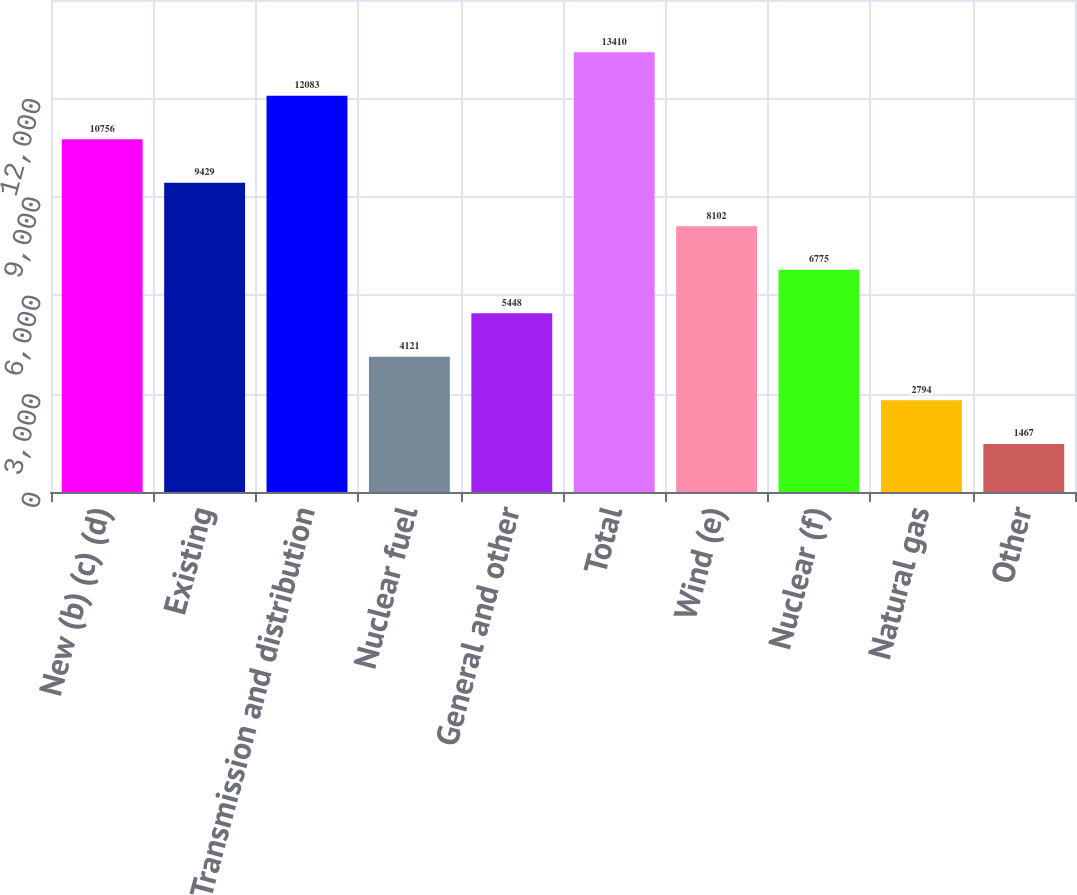<chart> <loc_0><loc_0><loc_500><loc_500><bar_chart><fcel>New (b) (c) (d)<fcel>Existing<fcel>Transmission and distribution<fcel>Nuclear fuel<fcel>General and other<fcel>Total<fcel>Wind (e)<fcel>Nuclear (f)<fcel>Natural gas<fcel>Other<nl><fcel>10756<fcel>9429<fcel>12083<fcel>4121<fcel>5448<fcel>13410<fcel>8102<fcel>6775<fcel>2794<fcel>1467<nl></chart> 